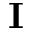<formula> <loc_0><loc_0><loc_500><loc_500>I</formula> 